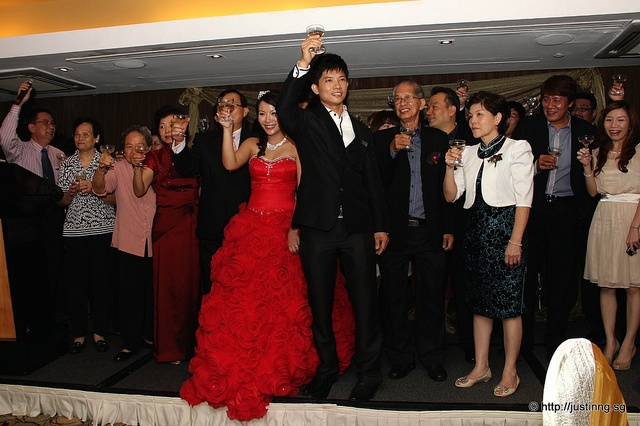Describe the objects in this image and their specific colors. I can see people in orange, black, brown, ivory, and maroon tones, people in orange, brown, maroon, and black tones, people in orange, black, lightgray, gray, and brown tones, people in orange, black, gray, maroon, and brown tones, and people in orange, black, gray, and maroon tones in this image. 